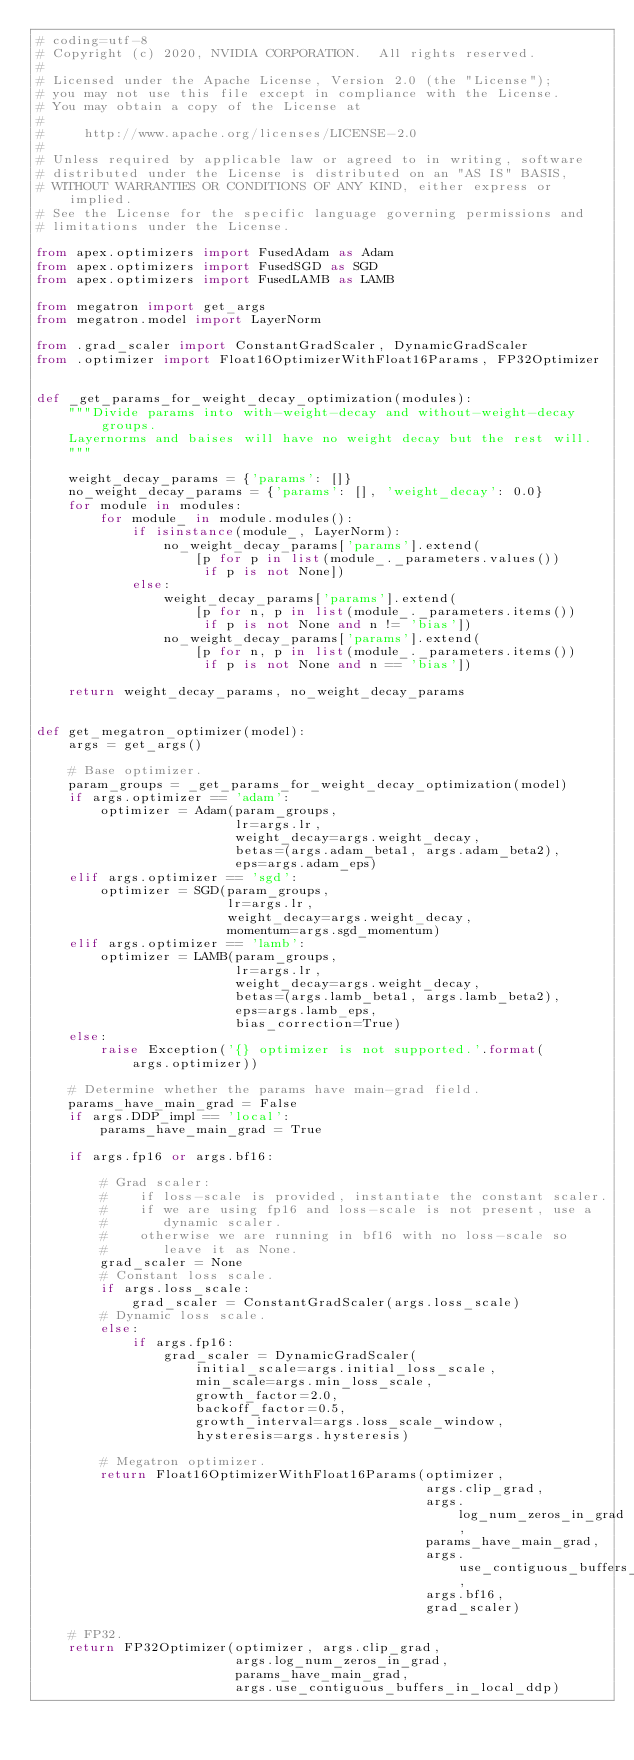<code> <loc_0><loc_0><loc_500><loc_500><_Python_># coding=utf-8
# Copyright (c) 2020, NVIDIA CORPORATION.  All rights reserved.
#
# Licensed under the Apache License, Version 2.0 (the "License");
# you may not use this file except in compliance with the License.
# You may obtain a copy of the License at
#
#     http://www.apache.org/licenses/LICENSE-2.0
#
# Unless required by applicable law or agreed to in writing, software
# distributed under the License is distributed on an "AS IS" BASIS,
# WITHOUT WARRANTIES OR CONDITIONS OF ANY KIND, either express or implied.
# See the License for the specific language governing permissions and
# limitations under the License.

from apex.optimizers import FusedAdam as Adam
from apex.optimizers import FusedSGD as SGD
from apex.optimizers import FusedLAMB as LAMB

from megatron import get_args
from megatron.model import LayerNorm

from .grad_scaler import ConstantGradScaler, DynamicGradScaler
from .optimizer import Float16OptimizerWithFloat16Params, FP32Optimizer


def _get_params_for_weight_decay_optimization(modules):
    """Divide params into with-weight-decay and without-weight-decay groups.
    Layernorms and baises will have no weight decay but the rest will.
    """

    weight_decay_params = {'params': []}
    no_weight_decay_params = {'params': [], 'weight_decay': 0.0}
    for module in modules:
        for module_ in module.modules():
            if isinstance(module_, LayerNorm):
                no_weight_decay_params['params'].extend(
                    [p for p in list(module_._parameters.values())
                     if p is not None])
            else:
                weight_decay_params['params'].extend(
                    [p for n, p in list(module_._parameters.items())
                     if p is not None and n != 'bias'])
                no_weight_decay_params['params'].extend(
                    [p for n, p in list(module_._parameters.items())
                     if p is not None and n == 'bias'])

    return weight_decay_params, no_weight_decay_params


def get_megatron_optimizer(model):
    args = get_args()

    # Base optimizer.
    param_groups = _get_params_for_weight_decay_optimization(model)
    if args.optimizer == 'adam':
        optimizer = Adam(param_groups,
                         lr=args.lr,
                         weight_decay=args.weight_decay,
                         betas=(args.adam_beta1, args.adam_beta2),
                         eps=args.adam_eps)
    elif args.optimizer == 'sgd':
        optimizer = SGD(param_groups,
                        lr=args.lr,
                        weight_decay=args.weight_decay,
                        momentum=args.sgd_momentum)
    elif args.optimizer == 'lamb':
        optimizer = LAMB(param_groups,
                         lr=args.lr,
                         weight_decay=args.weight_decay,
                         betas=(args.lamb_beta1, args.lamb_beta2),
                         eps=args.lamb_eps,
                         bias_correction=True)
    else:
        raise Exception('{} optimizer is not supported.'.format(
            args.optimizer))

    # Determine whether the params have main-grad field.
    params_have_main_grad = False
    if args.DDP_impl == 'local':
        params_have_main_grad = True

    if args.fp16 or args.bf16:

        # Grad scaler:
        #    if loss-scale is provided, instantiate the constant scaler.
        #    if we are using fp16 and loss-scale is not present, use a
        #       dynamic scaler.
        #    otherwise we are running in bf16 with no loss-scale so
        #       leave it as None.
        grad_scaler = None
        # Constant loss scale.
        if args.loss_scale:
            grad_scaler = ConstantGradScaler(args.loss_scale)
        # Dynamic loss scale.
        else:
            if args.fp16:
                grad_scaler = DynamicGradScaler(
                    initial_scale=args.initial_loss_scale,
                    min_scale=args.min_loss_scale,
                    growth_factor=2.0,
                    backoff_factor=0.5,
                    growth_interval=args.loss_scale_window,
                    hysteresis=args.hysteresis)

        # Megatron optimizer.
        return Float16OptimizerWithFloat16Params(optimizer,
                                                 args.clip_grad,
                                                 args.log_num_zeros_in_grad,
                                                 params_have_main_grad,
                                                 args.use_contiguous_buffers_in_local_ddp,
                                                 args.bf16,
                                                 grad_scaler)

    # FP32.
    return FP32Optimizer(optimizer, args.clip_grad,
                         args.log_num_zeros_in_grad,
                         params_have_main_grad,
                         args.use_contiguous_buffers_in_local_ddp)
</code> 